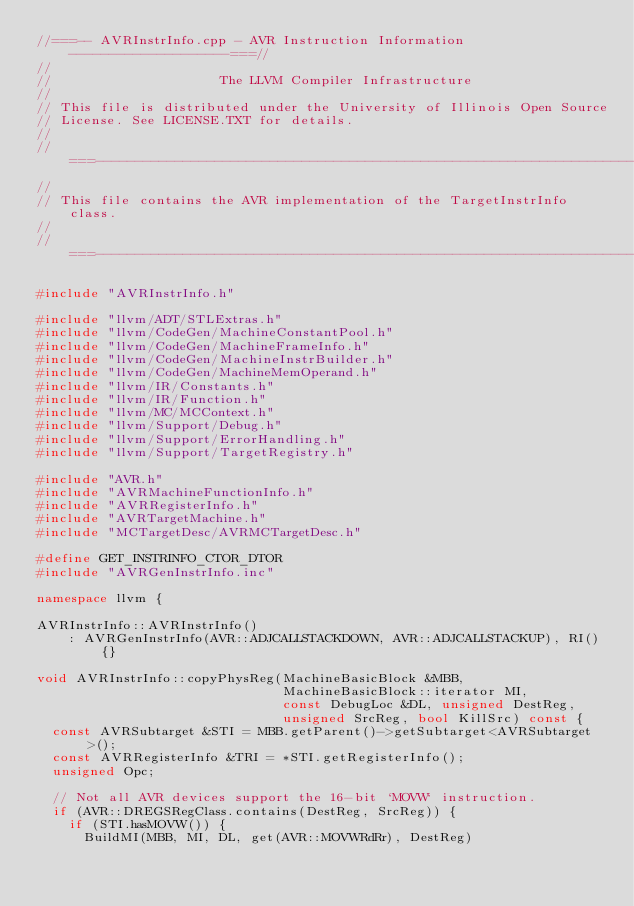Convert code to text. <code><loc_0><loc_0><loc_500><loc_500><_C++_>//===-- AVRInstrInfo.cpp - AVR Instruction Information --------------------===//
//
//                     The LLVM Compiler Infrastructure
//
// This file is distributed under the University of Illinois Open Source
// License. See LICENSE.TXT for details.
//
//===----------------------------------------------------------------------===//
//
// This file contains the AVR implementation of the TargetInstrInfo class.
//
//===----------------------------------------------------------------------===//

#include "AVRInstrInfo.h"

#include "llvm/ADT/STLExtras.h"
#include "llvm/CodeGen/MachineConstantPool.h"
#include "llvm/CodeGen/MachineFrameInfo.h"
#include "llvm/CodeGen/MachineInstrBuilder.h"
#include "llvm/CodeGen/MachineMemOperand.h"
#include "llvm/IR/Constants.h"
#include "llvm/IR/Function.h"
#include "llvm/MC/MCContext.h"
#include "llvm/Support/Debug.h"
#include "llvm/Support/ErrorHandling.h"
#include "llvm/Support/TargetRegistry.h"

#include "AVR.h"
#include "AVRMachineFunctionInfo.h"
#include "AVRRegisterInfo.h"
#include "AVRTargetMachine.h"
#include "MCTargetDesc/AVRMCTargetDesc.h"

#define GET_INSTRINFO_CTOR_DTOR
#include "AVRGenInstrInfo.inc"

namespace llvm {

AVRInstrInfo::AVRInstrInfo()
    : AVRGenInstrInfo(AVR::ADJCALLSTACKDOWN, AVR::ADJCALLSTACKUP), RI() {}

void AVRInstrInfo::copyPhysReg(MachineBasicBlock &MBB,
                               MachineBasicBlock::iterator MI,
                               const DebugLoc &DL, unsigned DestReg,
                               unsigned SrcReg, bool KillSrc) const {
  const AVRSubtarget &STI = MBB.getParent()->getSubtarget<AVRSubtarget>();
  const AVRRegisterInfo &TRI = *STI.getRegisterInfo();
  unsigned Opc;

  // Not all AVR devices support the 16-bit `MOVW` instruction.
  if (AVR::DREGSRegClass.contains(DestReg, SrcReg)) {
    if (STI.hasMOVW()) {
      BuildMI(MBB, MI, DL, get(AVR::MOVWRdRr), DestReg)</code> 